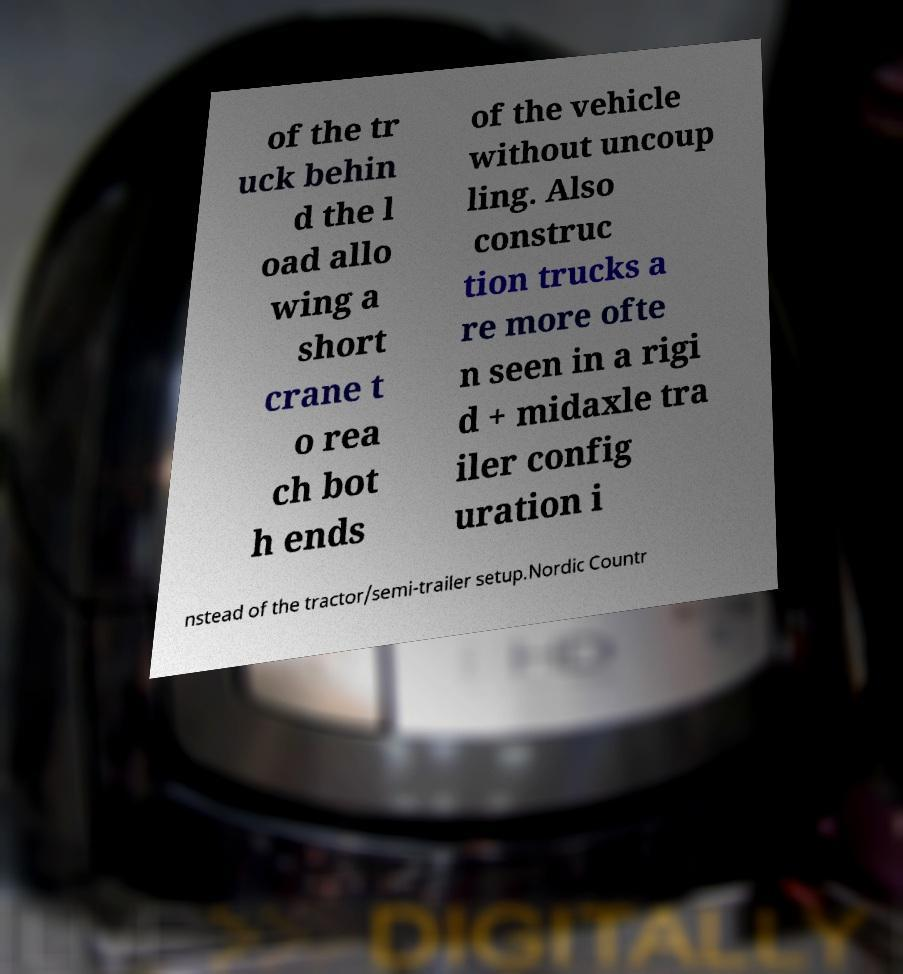There's text embedded in this image that I need extracted. Can you transcribe it verbatim? of the tr uck behin d the l oad allo wing a short crane t o rea ch bot h ends of the vehicle without uncoup ling. Also construc tion trucks a re more ofte n seen in a rigi d + midaxle tra iler config uration i nstead of the tractor/semi-trailer setup.Nordic Countr 